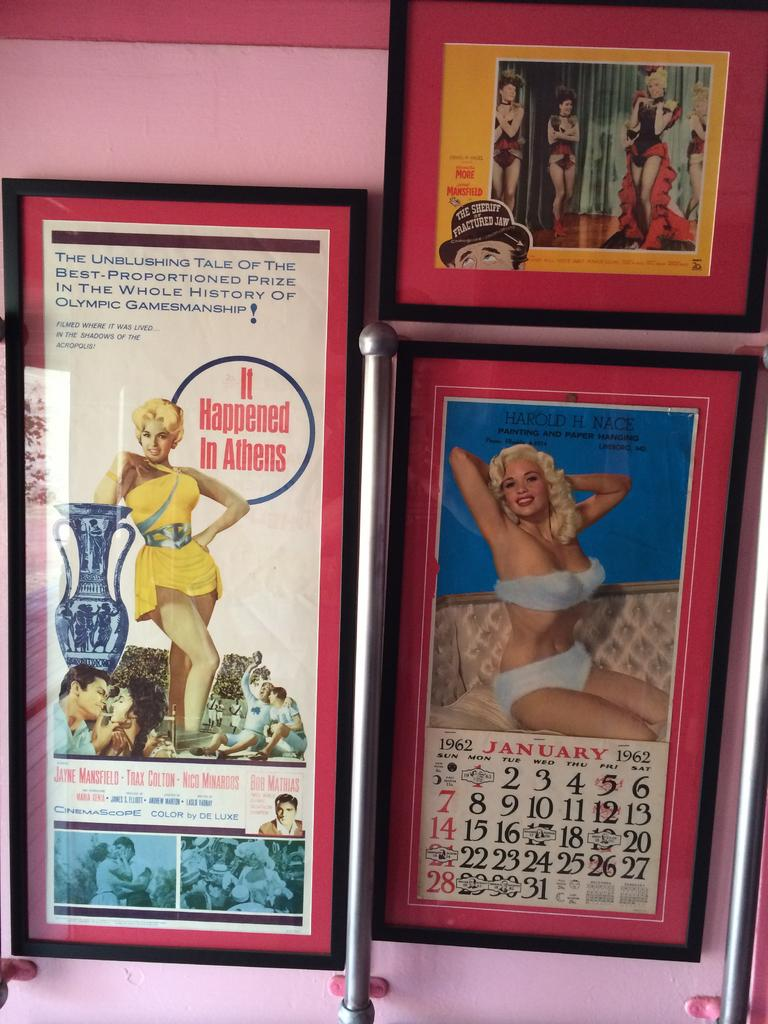What is hanging on the wall in the image? There are frames on a wall in the image. What can be found inside the frames? The frames contain pictures. Are there any words or letters on the frames? Yes, there is text on the frames. What else can be seen in the image besides the frames? Metal poles are visible in the image. What type of oranges are being read in the image? There are no oranges or reading material present in the image. 